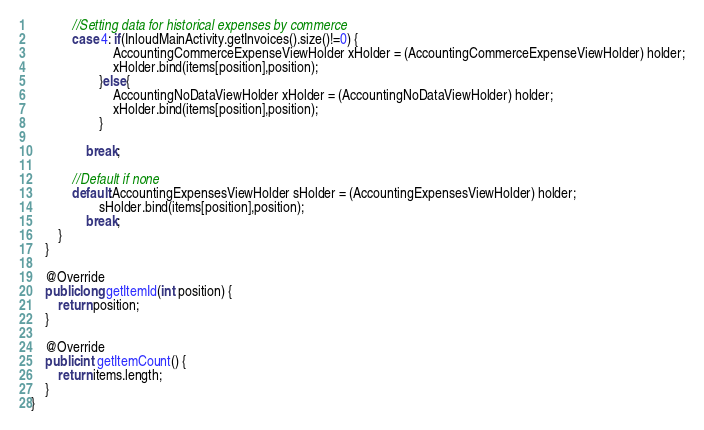Convert code to text. <code><loc_0><loc_0><loc_500><loc_500><_Java_>            //Setting data for historical expenses by commerce
            case 4: if(InloudMainActivity.getInvoices().size()!=0) {
                        AccountingCommerceExpenseViewHolder xHolder = (AccountingCommerceExpenseViewHolder) holder;
                        xHolder.bind(items[position],position);
                    }else{
                        AccountingNoDataViewHolder xHolder = (AccountingNoDataViewHolder) holder;
                        xHolder.bind(items[position],position);
                    }

                break;

            //Default if none
            default:AccountingExpensesViewHolder sHolder = (AccountingExpensesViewHolder) holder;
                    sHolder.bind(items[position],position);
                break;
        }
    }

    @Override
    public long getItemId(int position) {
        return position;
    }

    @Override
    public int getItemCount() {
        return items.length;
    }
}</code> 